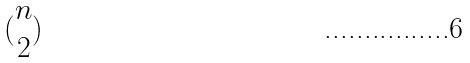Convert formula to latex. <formula><loc_0><loc_0><loc_500><loc_500>( \begin{matrix} n \\ 2 \end{matrix} )</formula> 